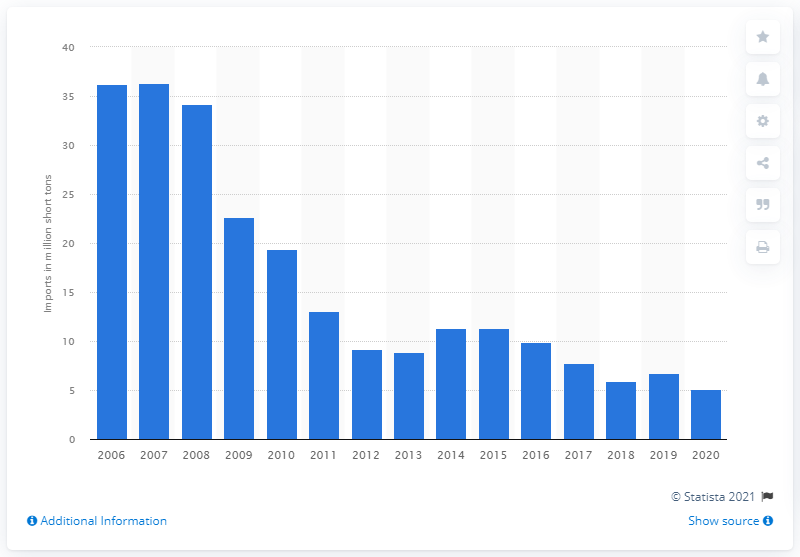Point out several critical features in this image. In 2006, imports of coal in the United States began to decline. In 2020, the quantity of coal imported into the United States decreased to 5.1 million short tons, as compared to the previous year. In 2007, the peak amount of short tons of coal imported into the United States was 36.35. 